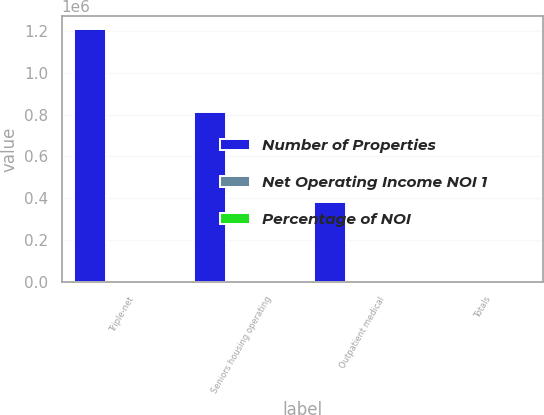<chart> <loc_0><loc_0><loc_500><loc_500><stacked_bar_chart><ecel><fcel>Triple-net<fcel>Seniors housing operating<fcel>Outpatient medical<fcel>Totals<nl><fcel>Number of Properties<fcel>1.20886e+06<fcel>814114<fcel>380264<fcel>420<nl><fcel>Net Operating Income NOI 1<fcel>50.3<fcel>33.9<fcel>15.8<fcel>100<nl><fcel>Percentage of NOI<fcel>631<fcel>420<fcel>262<fcel>1313<nl></chart> 